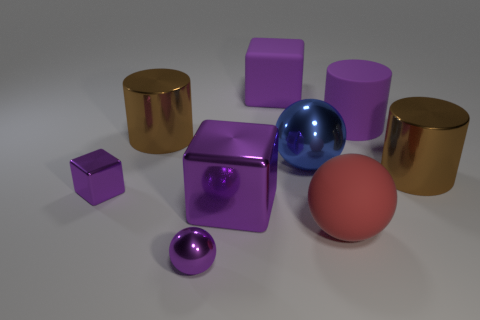There is a purple metallic object behind the big metal block; how many cylinders are on the left side of it?
Provide a short and direct response. 0. What is the ball that is both right of the big purple metal thing and in front of the large blue thing made of?
Keep it short and to the point. Rubber. There is a purple shiny thing that is the same size as the blue metal ball; what is its shape?
Your response must be concise. Cube. There is a shiny thing that is on the right side of the large ball that is behind the purple metallic block that is to the right of the small purple ball; what is its color?
Offer a terse response. Brown. How many objects are either large brown objects right of the large blue object or tiny green blocks?
Give a very brief answer. 1. There is another sphere that is the same size as the blue ball; what material is it?
Your answer should be compact. Rubber. What material is the big brown cylinder behind the big ball behind the purple block in front of the tiny shiny cube made of?
Offer a terse response. Metal. The rubber block has what color?
Provide a short and direct response. Purple. What number of large objects are blue metallic balls or purple metallic balls?
Keep it short and to the point. 1. There is a cylinder that is the same color as the tiny metallic block; what is its material?
Provide a succinct answer. Rubber. 